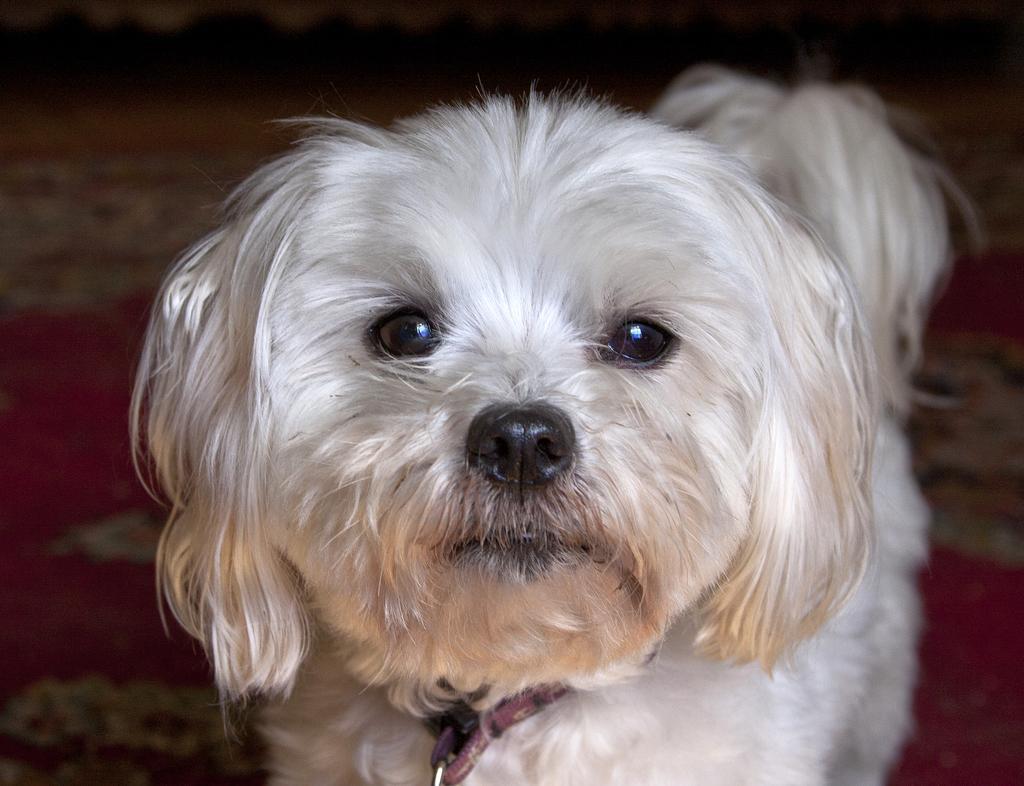How would you summarize this image in a sentence or two? In this picture I can see a dog in front, which is of white color and I see that it is blurred in the background. 